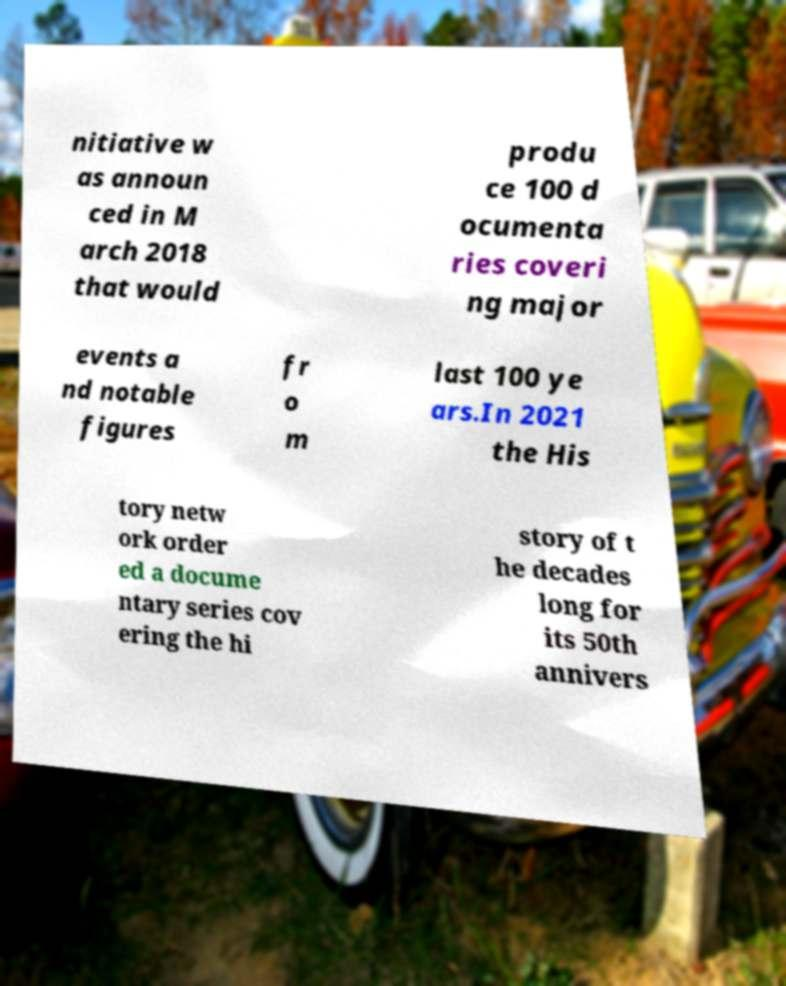Could you extract and type out the text from this image? nitiative w as announ ced in M arch 2018 that would produ ce 100 d ocumenta ries coveri ng major events a nd notable figures fr o m last 100 ye ars.In 2021 the His tory netw ork order ed a docume ntary series cov ering the hi story of t he decades long for its 50th annivers 